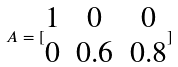Convert formula to latex. <formula><loc_0><loc_0><loc_500><loc_500>A = [ \begin{matrix} 1 & 0 & 0 \\ 0 & 0 . 6 & 0 . 8 \end{matrix} ]</formula> 